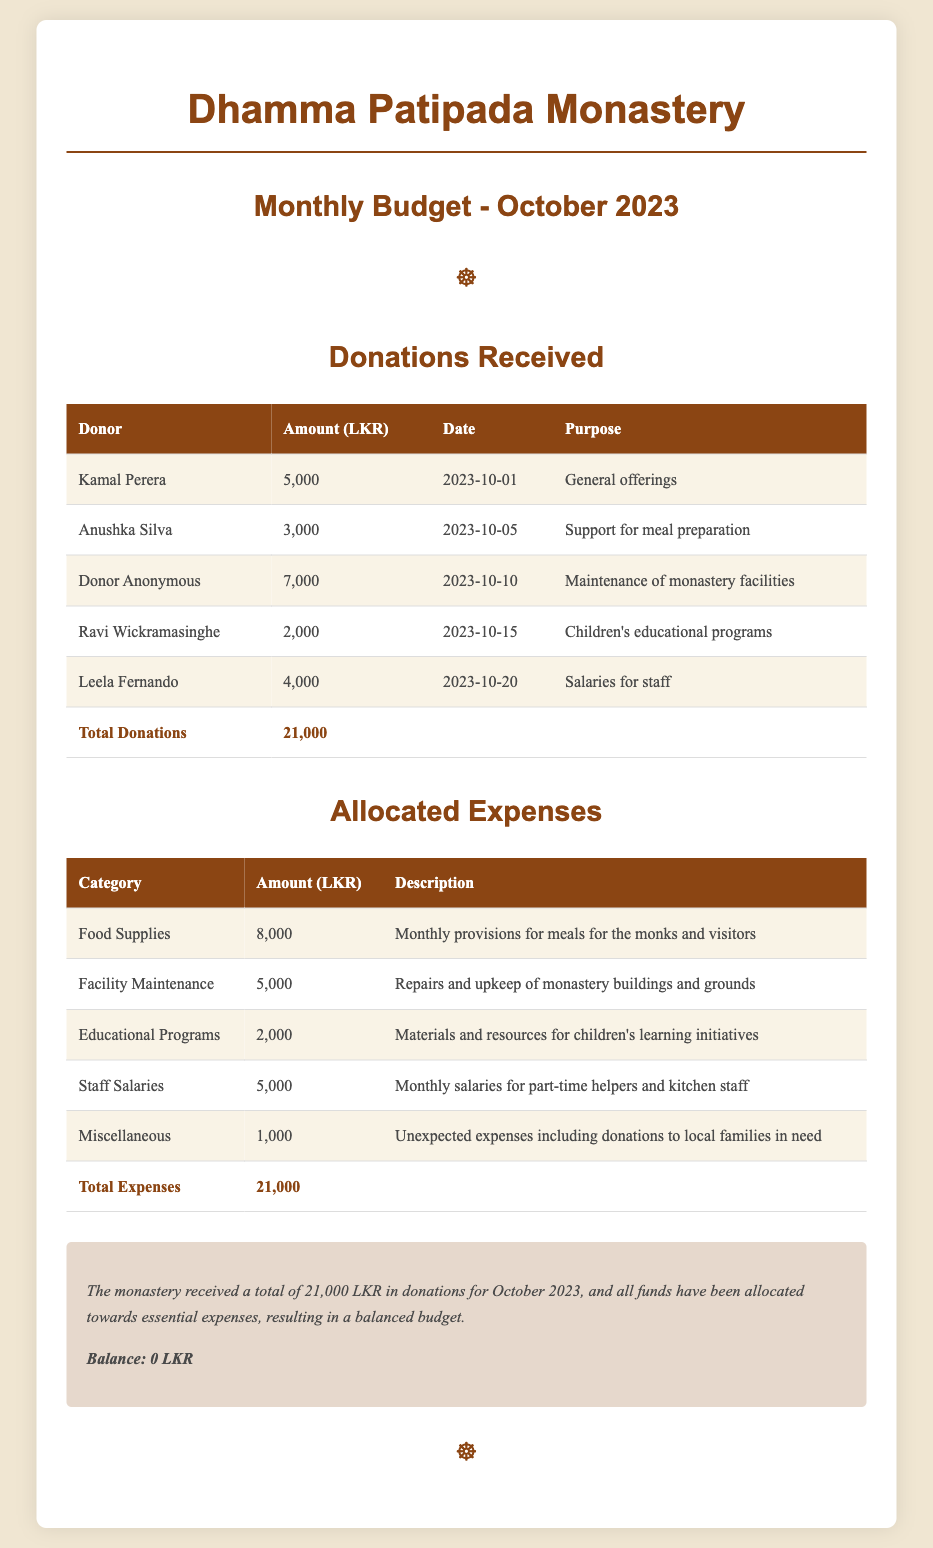What was the total amount of donations received? The total donations are listed in the table and amount to 21,000 LKR.
Answer: 21,000 LKR Who made the largest donation? The largest individual donation recorded is 7,000 LKR from an anonymous donor for maintenance purposes.
Answer: Donor Anonymous What was the purpose of the donation made by Anushka Silva? The donation by Anushka Silva was specifically for support for meal preparation.
Answer: Support for meal preparation How much was allocated for food supplies? The document specifies that 8,000 LKR was allocated for food supplies.
Answer: 8,000 LKR What is the total allocated expenses? The total expenses can be found at the end of the expenses table, summing to 21,000 LKR.
Answer: 21,000 LKR How many categories of expenses are listed? The expense categories are outlined in the table, totaling five different categories.
Answer: Five What was the description of the miscellaneous expenses category? The miscellaneous category includes unexpected expenses such as donations to local families in need.
Answer: Unexpected expenses including donations to local families in need What balance remains after expenses? The summary states that all funds have been allocated, resulting in a balance of 0 LKR.
Answer: 0 LKR What is the name of the monastery? The name of the monastery is mentioned in the header of the document as Dhamma Patipada Monastery.
Answer: Dhamma Patipada Monastery What is the total amount allocated for educational programs? According to the document, 2,000 LKR is allocated for educational programs.
Answer: 2,000 LKR 